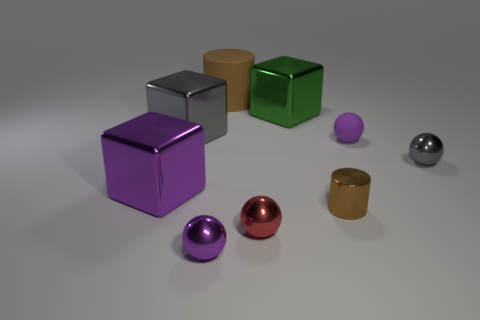Add 1 gray things. How many objects exist? 10 Subtract all cylinders. How many objects are left? 7 Subtract 2 purple balls. How many objects are left? 7 Subtract all big brown rubber objects. Subtract all large green things. How many objects are left? 7 Add 4 small brown objects. How many small brown objects are left? 5 Add 9 large red cylinders. How many large red cylinders exist? 9 